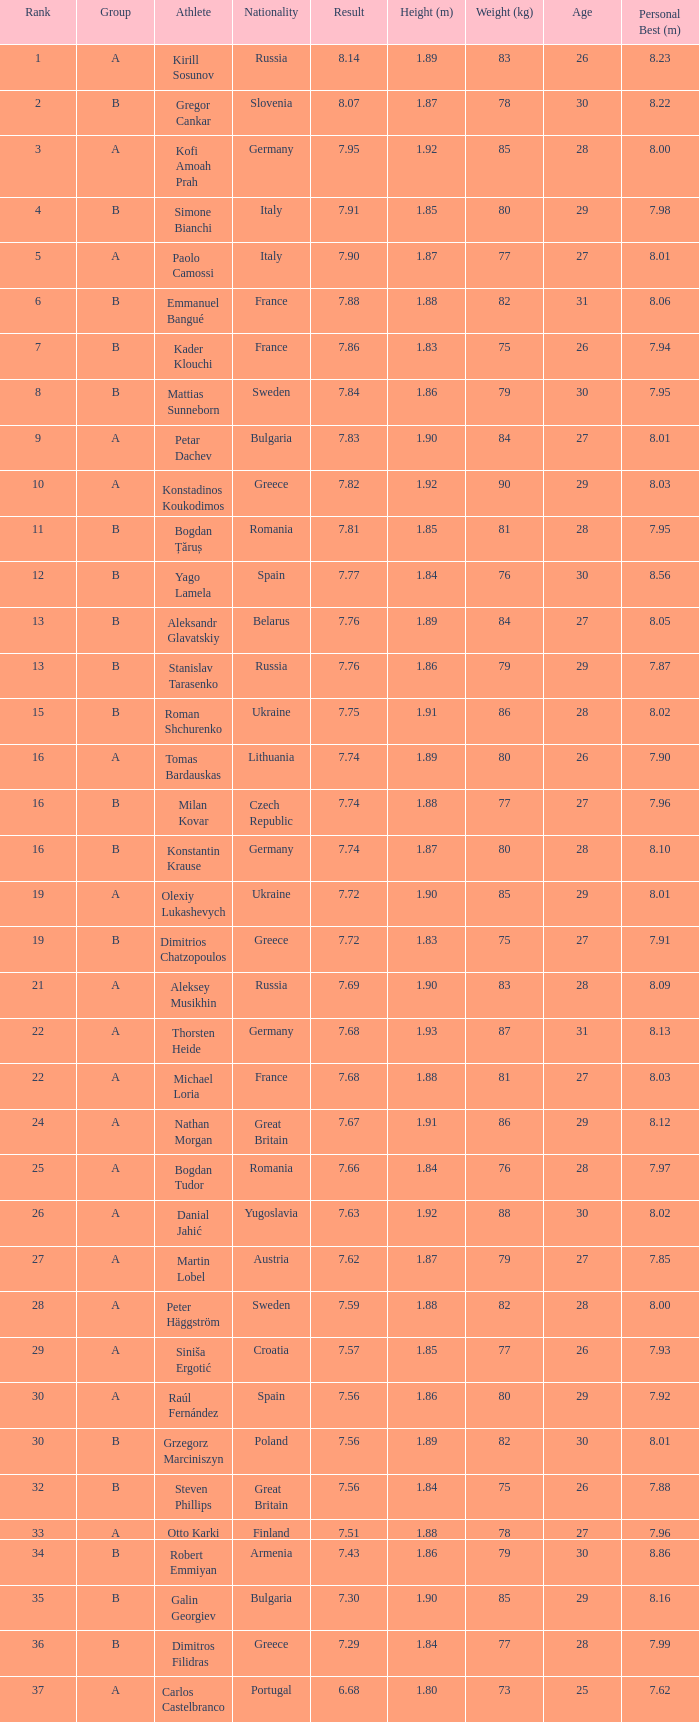Which player's ranking is greater than 15 when the performance is less than Steven Phillips. 